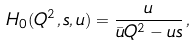<formula> <loc_0><loc_0><loc_500><loc_500>H _ { 0 } ( Q ^ { 2 } , s , u ) = \frac { u } { \bar { u } Q ^ { 2 } - u s } \, ,</formula> 